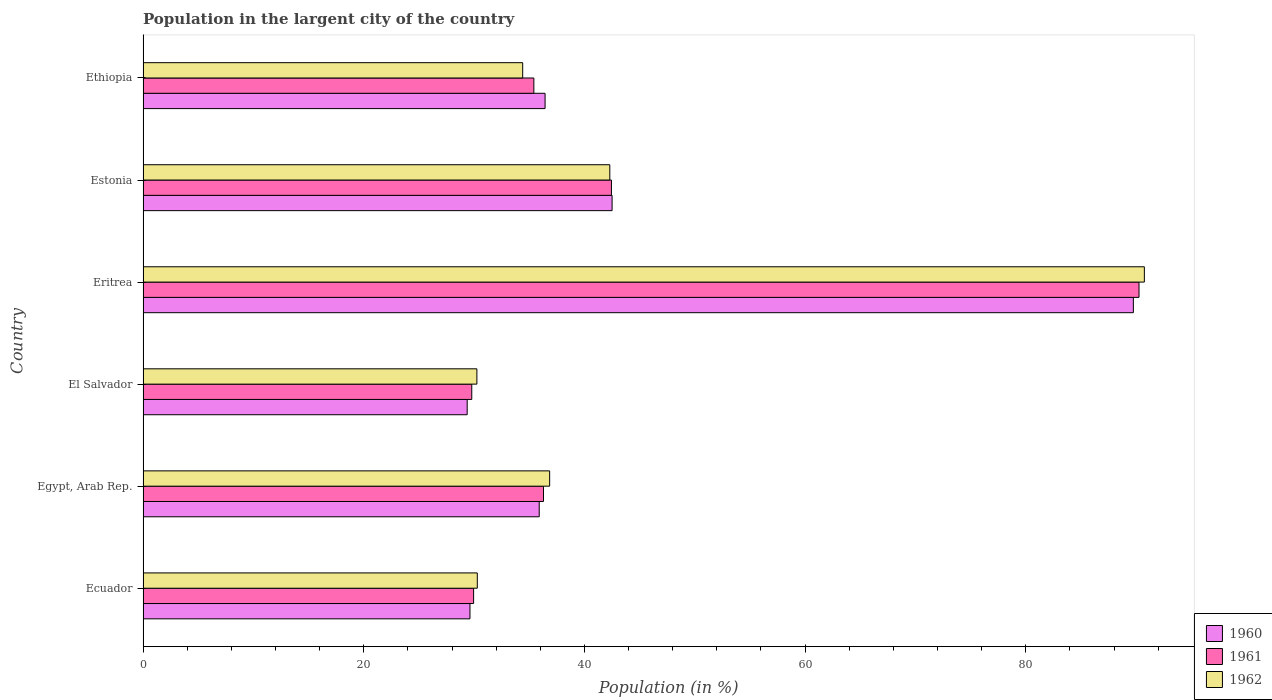Are the number of bars per tick equal to the number of legend labels?
Your answer should be very brief. Yes. Are the number of bars on each tick of the Y-axis equal?
Your answer should be very brief. Yes. How many bars are there on the 4th tick from the bottom?
Make the answer very short. 3. What is the label of the 2nd group of bars from the top?
Offer a very short reply. Estonia. What is the percentage of population in the largent city in 1960 in Eritrea?
Give a very brief answer. 89.75. Across all countries, what is the maximum percentage of population in the largent city in 1962?
Give a very brief answer. 90.74. Across all countries, what is the minimum percentage of population in the largent city in 1961?
Your answer should be very brief. 29.79. In which country was the percentage of population in the largent city in 1962 maximum?
Make the answer very short. Eritrea. In which country was the percentage of population in the largent city in 1960 minimum?
Your answer should be very brief. El Salvador. What is the total percentage of population in the largent city in 1961 in the graph?
Offer a very short reply. 264.16. What is the difference between the percentage of population in the largent city in 1960 in Egypt, Arab Rep. and that in Estonia?
Offer a terse response. -6.6. What is the difference between the percentage of population in the largent city in 1961 in El Salvador and the percentage of population in the largent city in 1962 in Estonia?
Provide a succinct answer. -12.51. What is the average percentage of population in the largent city in 1962 per country?
Keep it short and to the point. 44.14. What is the difference between the percentage of population in the largent city in 1960 and percentage of population in the largent city in 1961 in Ecuador?
Offer a terse response. -0.33. In how many countries, is the percentage of population in the largent city in 1962 greater than 40 %?
Make the answer very short. 2. What is the ratio of the percentage of population in the largent city in 1962 in Eritrea to that in Ethiopia?
Ensure brevity in your answer.  2.64. What is the difference between the highest and the second highest percentage of population in the largent city in 1960?
Ensure brevity in your answer.  47.24. What is the difference between the highest and the lowest percentage of population in the largent city in 1960?
Your response must be concise. 60.37. In how many countries, is the percentage of population in the largent city in 1960 greater than the average percentage of population in the largent city in 1960 taken over all countries?
Offer a terse response. 1. Is the sum of the percentage of population in the largent city in 1962 in Egypt, Arab Rep. and Ethiopia greater than the maximum percentage of population in the largent city in 1961 across all countries?
Make the answer very short. No. What does the 2nd bar from the top in Egypt, Arab Rep. represents?
Ensure brevity in your answer.  1961. Are all the bars in the graph horizontal?
Keep it short and to the point. Yes. How many countries are there in the graph?
Your answer should be very brief. 6. What is the difference between two consecutive major ticks on the X-axis?
Your answer should be very brief. 20. Are the values on the major ticks of X-axis written in scientific E-notation?
Give a very brief answer. No. Where does the legend appear in the graph?
Provide a succinct answer. Bottom right. What is the title of the graph?
Ensure brevity in your answer.  Population in the largent city of the country. What is the Population (in %) of 1960 in Ecuador?
Your answer should be very brief. 29.63. What is the Population (in %) in 1961 in Ecuador?
Ensure brevity in your answer.  29.96. What is the Population (in %) in 1962 in Ecuador?
Provide a succinct answer. 30.29. What is the Population (in %) of 1960 in Egypt, Arab Rep.?
Your answer should be compact. 35.9. What is the Population (in %) of 1961 in Egypt, Arab Rep.?
Give a very brief answer. 36.29. What is the Population (in %) of 1962 in Egypt, Arab Rep.?
Offer a terse response. 36.85. What is the Population (in %) in 1960 in El Salvador?
Provide a short and direct response. 29.37. What is the Population (in %) of 1961 in El Salvador?
Make the answer very short. 29.79. What is the Population (in %) in 1962 in El Salvador?
Provide a short and direct response. 30.25. What is the Population (in %) of 1960 in Eritrea?
Offer a very short reply. 89.75. What is the Population (in %) of 1961 in Eritrea?
Ensure brevity in your answer.  90.26. What is the Population (in %) of 1962 in Eritrea?
Offer a very short reply. 90.74. What is the Population (in %) of 1960 in Estonia?
Your answer should be compact. 42.51. What is the Population (in %) in 1961 in Estonia?
Your answer should be very brief. 42.45. What is the Population (in %) in 1962 in Estonia?
Give a very brief answer. 42.3. What is the Population (in %) of 1960 in Ethiopia?
Your answer should be very brief. 36.43. What is the Population (in %) of 1961 in Ethiopia?
Give a very brief answer. 35.42. What is the Population (in %) of 1962 in Ethiopia?
Keep it short and to the point. 34.4. Across all countries, what is the maximum Population (in %) in 1960?
Ensure brevity in your answer.  89.75. Across all countries, what is the maximum Population (in %) in 1961?
Your answer should be very brief. 90.26. Across all countries, what is the maximum Population (in %) in 1962?
Offer a very short reply. 90.74. Across all countries, what is the minimum Population (in %) of 1960?
Your answer should be compact. 29.37. Across all countries, what is the minimum Population (in %) in 1961?
Provide a succinct answer. 29.79. Across all countries, what is the minimum Population (in %) in 1962?
Offer a very short reply. 30.25. What is the total Population (in %) in 1960 in the graph?
Offer a terse response. 263.59. What is the total Population (in %) of 1961 in the graph?
Your response must be concise. 264.16. What is the total Population (in %) in 1962 in the graph?
Your answer should be very brief. 264.84. What is the difference between the Population (in %) of 1960 in Ecuador and that in Egypt, Arab Rep.?
Give a very brief answer. -6.28. What is the difference between the Population (in %) in 1961 in Ecuador and that in Egypt, Arab Rep.?
Give a very brief answer. -6.33. What is the difference between the Population (in %) of 1962 in Ecuador and that in Egypt, Arab Rep.?
Offer a very short reply. -6.56. What is the difference between the Population (in %) of 1960 in Ecuador and that in El Salvador?
Offer a very short reply. 0.25. What is the difference between the Population (in %) of 1961 in Ecuador and that in El Salvador?
Make the answer very short. 0.17. What is the difference between the Population (in %) in 1962 in Ecuador and that in El Salvador?
Keep it short and to the point. 0.04. What is the difference between the Population (in %) of 1960 in Ecuador and that in Eritrea?
Offer a very short reply. -60.12. What is the difference between the Population (in %) of 1961 in Ecuador and that in Eritrea?
Offer a very short reply. -60.3. What is the difference between the Population (in %) of 1962 in Ecuador and that in Eritrea?
Your answer should be compact. -60.45. What is the difference between the Population (in %) in 1960 in Ecuador and that in Estonia?
Make the answer very short. -12.88. What is the difference between the Population (in %) in 1961 in Ecuador and that in Estonia?
Your answer should be compact. -12.49. What is the difference between the Population (in %) in 1962 in Ecuador and that in Estonia?
Offer a terse response. -12.01. What is the difference between the Population (in %) in 1960 in Ecuador and that in Ethiopia?
Make the answer very short. -6.81. What is the difference between the Population (in %) of 1961 in Ecuador and that in Ethiopia?
Give a very brief answer. -5.46. What is the difference between the Population (in %) of 1962 in Ecuador and that in Ethiopia?
Your response must be concise. -4.11. What is the difference between the Population (in %) of 1960 in Egypt, Arab Rep. and that in El Salvador?
Provide a succinct answer. 6.53. What is the difference between the Population (in %) of 1961 in Egypt, Arab Rep. and that in El Salvador?
Keep it short and to the point. 6.5. What is the difference between the Population (in %) of 1962 in Egypt, Arab Rep. and that in El Salvador?
Your response must be concise. 6.59. What is the difference between the Population (in %) in 1960 in Egypt, Arab Rep. and that in Eritrea?
Give a very brief answer. -53.85. What is the difference between the Population (in %) of 1961 in Egypt, Arab Rep. and that in Eritrea?
Your answer should be compact. -53.97. What is the difference between the Population (in %) in 1962 in Egypt, Arab Rep. and that in Eritrea?
Your response must be concise. -53.9. What is the difference between the Population (in %) in 1960 in Egypt, Arab Rep. and that in Estonia?
Offer a very short reply. -6.61. What is the difference between the Population (in %) in 1961 in Egypt, Arab Rep. and that in Estonia?
Your answer should be very brief. -6.16. What is the difference between the Population (in %) in 1962 in Egypt, Arab Rep. and that in Estonia?
Make the answer very short. -5.45. What is the difference between the Population (in %) in 1960 in Egypt, Arab Rep. and that in Ethiopia?
Make the answer very short. -0.53. What is the difference between the Population (in %) of 1961 in Egypt, Arab Rep. and that in Ethiopia?
Your answer should be compact. 0.87. What is the difference between the Population (in %) in 1962 in Egypt, Arab Rep. and that in Ethiopia?
Give a very brief answer. 2.44. What is the difference between the Population (in %) in 1960 in El Salvador and that in Eritrea?
Provide a short and direct response. -60.37. What is the difference between the Population (in %) in 1961 in El Salvador and that in Eritrea?
Keep it short and to the point. -60.47. What is the difference between the Population (in %) in 1962 in El Salvador and that in Eritrea?
Provide a succinct answer. -60.49. What is the difference between the Population (in %) in 1960 in El Salvador and that in Estonia?
Offer a very short reply. -13.13. What is the difference between the Population (in %) of 1961 in El Salvador and that in Estonia?
Provide a succinct answer. -12.66. What is the difference between the Population (in %) of 1962 in El Salvador and that in Estonia?
Provide a short and direct response. -12.05. What is the difference between the Population (in %) in 1960 in El Salvador and that in Ethiopia?
Provide a short and direct response. -7.06. What is the difference between the Population (in %) of 1961 in El Salvador and that in Ethiopia?
Offer a very short reply. -5.63. What is the difference between the Population (in %) in 1962 in El Salvador and that in Ethiopia?
Your response must be concise. -4.15. What is the difference between the Population (in %) in 1960 in Eritrea and that in Estonia?
Your answer should be very brief. 47.24. What is the difference between the Population (in %) in 1961 in Eritrea and that in Estonia?
Offer a very short reply. 47.81. What is the difference between the Population (in %) of 1962 in Eritrea and that in Estonia?
Keep it short and to the point. 48.44. What is the difference between the Population (in %) in 1960 in Eritrea and that in Ethiopia?
Provide a succinct answer. 53.31. What is the difference between the Population (in %) of 1961 in Eritrea and that in Ethiopia?
Your answer should be very brief. 54.84. What is the difference between the Population (in %) in 1962 in Eritrea and that in Ethiopia?
Keep it short and to the point. 56.34. What is the difference between the Population (in %) in 1960 in Estonia and that in Ethiopia?
Provide a short and direct response. 6.07. What is the difference between the Population (in %) of 1961 in Estonia and that in Ethiopia?
Give a very brief answer. 7.03. What is the difference between the Population (in %) in 1962 in Estonia and that in Ethiopia?
Keep it short and to the point. 7.9. What is the difference between the Population (in %) in 1960 in Ecuador and the Population (in %) in 1961 in Egypt, Arab Rep.?
Give a very brief answer. -6.66. What is the difference between the Population (in %) of 1960 in Ecuador and the Population (in %) of 1962 in Egypt, Arab Rep.?
Offer a terse response. -7.22. What is the difference between the Population (in %) in 1961 in Ecuador and the Population (in %) in 1962 in Egypt, Arab Rep.?
Keep it short and to the point. -6.89. What is the difference between the Population (in %) in 1960 in Ecuador and the Population (in %) in 1961 in El Salvador?
Ensure brevity in your answer.  -0.16. What is the difference between the Population (in %) in 1960 in Ecuador and the Population (in %) in 1962 in El Salvador?
Provide a short and direct response. -0.63. What is the difference between the Population (in %) of 1961 in Ecuador and the Population (in %) of 1962 in El Salvador?
Make the answer very short. -0.3. What is the difference between the Population (in %) of 1960 in Ecuador and the Population (in %) of 1961 in Eritrea?
Your response must be concise. -60.63. What is the difference between the Population (in %) of 1960 in Ecuador and the Population (in %) of 1962 in Eritrea?
Offer a terse response. -61.12. What is the difference between the Population (in %) of 1961 in Ecuador and the Population (in %) of 1962 in Eritrea?
Your answer should be very brief. -60.79. What is the difference between the Population (in %) of 1960 in Ecuador and the Population (in %) of 1961 in Estonia?
Make the answer very short. -12.82. What is the difference between the Population (in %) in 1960 in Ecuador and the Population (in %) in 1962 in Estonia?
Offer a very short reply. -12.67. What is the difference between the Population (in %) in 1961 in Ecuador and the Population (in %) in 1962 in Estonia?
Your response must be concise. -12.34. What is the difference between the Population (in %) in 1960 in Ecuador and the Population (in %) in 1961 in Ethiopia?
Make the answer very short. -5.79. What is the difference between the Population (in %) in 1960 in Ecuador and the Population (in %) in 1962 in Ethiopia?
Your response must be concise. -4.78. What is the difference between the Population (in %) in 1961 in Ecuador and the Population (in %) in 1962 in Ethiopia?
Ensure brevity in your answer.  -4.45. What is the difference between the Population (in %) in 1960 in Egypt, Arab Rep. and the Population (in %) in 1961 in El Salvador?
Provide a short and direct response. 6.11. What is the difference between the Population (in %) of 1960 in Egypt, Arab Rep. and the Population (in %) of 1962 in El Salvador?
Give a very brief answer. 5.65. What is the difference between the Population (in %) of 1961 in Egypt, Arab Rep. and the Population (in %) of 1962 in El Salvador?
Your answer should be very brief. 6.04. What is the difference between the Population (in %) of 1960 in Egypt, Arab Rep. and the Population (in %) of 1961 in Eritrea?
Keep it short and to the point. -54.36. What is the difference between the Population (in %) in 1960 in Egypt, Arab Rep. and the Population (in %) in 1962 in Eritrea?
Offer a very short reply. -54.84. What is the difference between the Population (in %) in 1961 in Egypt, Arab Rep. and the Population (in %) in 1962 in Eritrea?
Offer a terse response. -54.46. What is the difference between the Population (in %) of 1960 in Egypt, Arab Rep. and the Population (in %) of 1961 in Estonia?
Provide a short and direct response. -6.54. What is the difference between the Population (in %) in 1960 in Egypt, Arab Rep. and the Population (in %) in 1962 in Estonia?
Make the answer very short. -6.4. What is the difference between the Population (in %) in 1961 in Egypt, Arab Rep. and the Population (in %) in 1962 in Estonia?
Offer a terse response. -6.01. What is the difference between the Population (in %) in 1960 in Egypt, Arab Rep. and the Population (in %) in 1961 in Ethiopia?
Keep it short and to the point. 0.49. What is the difference between the Population (in %) of 1960 in Egypt, Arab Rep. and the Population (in %) of 1962 in Ethiopia?
Provide a short and direct response. 1.5. What is the difference between the Population (in %) in 1961 in Egypt, Arab Rep. and the Population (in %) in 1962 in Ethiopia?
Offer a very short reply. 1.88. What is the difference between the Population (in %) in 1960 in El Salvador and the Population (in %) in 1961 in Eritrea?
Provide a succinct answer. -60.89. What is the difference between the Population (in %) of 1960 in El Salvador and the Population (in %) of 1962 in Eritrea?
Provide a short and direct response. -61.37. What is the difference between the Population (in %) in 1961 in El Salvador and the Population (in %) in 1962 in Eritrea?
Keep it short and to the point. -60.96. What is the difference between the Population (in %) in 1960 in El Salvador and the Population (in %) in 1961 in Estonia?
Provide a succinct answer. -13.07. What is the difference between the Population (in %) of 1960 in El Salvador and the Population (in %) of 1962 in Estonia?
Your answer should be compact. -12.93. What is the difference between the Population (in %) in 1961 in El Salvador and the Population (in %) in 1962 in Estonia?
Keep it short and to the point. -12.51. What is the difference between the Population (in %) of 1960 in El Salvador and the Population (in %) of 1961 in Ethiopia?
Give a very brief answer. -6.04. What is the difference between the Population (in %) of 1960 in El Salvador and the Population (in %) of 1962 in Ethiopia?
Provide a short and direct response. -5.03. What is the difference between the Population (in %) in 1961 in El Salvador and the Population (in %) in 1962 in Ethiopia?
Your answer should be very brief. -4.61. What is the difference between the Population (in %) in 1960 in Eritrea and the Population (in %) in 1961 in Estonia?
Provide a succinct answer. 47.3. What is the difference between the Population (in %) of 1960 in Eritrea and the Population (in %) of 1962 in Estonia?
Keep it short and to the point. 47.45. What is the difference between the Population (in %) of 1961 in Eritrea and the Population (in %) of 1962 in Estonia?
Provide a short and direct response. 47.96. What is the difference between the Population (in %) of 1960 in Eritrea and the Population (in %) of 1961 in Ethiopia?
Provide a succinct answer. 54.33. What is the difference between the Population (in %) of 1960 in Eritrea and the Population (in %) of 1962 in Ethiopia?
Make the answer very short. 55.34. What is the difference between the Population (in %) in 1961 in Eritrea and the Population (in %) in 1962 in Ethiopia?
Your answer should be very brief. 55.86. What is the difference between the Population (in %) in 1960 in Estonia and the Population (in %) in 1961 in Ethiopia?
Make the answer very short. 7.09. What is the difference between the Population (in %) in 1960 in Estonia and the Population (in %) in 1962 in Ethiopia?
Your answer should be very brief. 8.1. What is the difference between the Population (in %) in 1961 in Estonia and the Population (in %) in 1962 in Ethiopia?
Your answer should be very brief. 8.04. What is the average Population (in %) of 1960 per country?
Offer a terse response. 43.93. What is the average Population (in %) of 1961 per country?
Make the answer very short. 44.03. What is the average Population (in %) of 1962 per country?
Provide a short and direct response. 44.14. What is the difference between the Population (in %) of 1960 and Population (in %) of 1961 in Ecuador?
Your response must be concise. -0.33. What is the difference between the Population (in %) of 1960 and Population (in %) of 1962 in Ecuador?
Your answer should be compact. -0.66. What is the difference between the Population (in %) of 1961 and Population (in %) of 1962 in Ecuador?
Your answer should be very brief. -0.33. What is the difference between the Population (in %) of 1960 and Population (in %) of 1961 in Egypt, Arab Rep.?
Your response must be concise. -0.39. What is the difference between the Population (in %) of 1960 and Population (in %) of 1962 in Egypt, Arab Rep.?
Provide a short and direct response. -0.95. What is the difference between the Population (in %) in 1961 and Population (in %) in 1962 in Egypt, Arab Rep.?
Make the answer very short. -0.56. What is the difference between the Population (in %) of 1960 and Population (in %) of 1961 in El Salvador?
Your response must be concise. -0.42. What is the difference between the Population (in %) of 1960 and Population (in %) of 1962 in El Salvador?
Provide a succinct answer. -0.88. What is the difference between the Population (in %) in 1961 and Population (in %) in 1962 in El Salvador?
Your response must be concise. -0.46. What is the difference between the Population (in %) in 1960 and Population (in %) in 1961 in Eritrea?
Provide a succinct answer. -0.51. What is the difference between the Population (in %) in 1960 and Population (in %) in 1962 in Eritrea?
Provide a short and direct response. -1. What is the difference between the Population (in %) of 1961 and Population (in %) of 1962 in Eritrea?
Give a very brief answer. -0.49. What is the difference between the Population (in %) of 1960 and Population (in %) of 1961 in Estonia?
Your answer should be very brief. 0.06. What is the difference between the Population (in %) of 1960 and Population (in %) of 1962 in Estonia?
Provide a short and direct response. 0.21. What is the difference between the Population (in %) in 1961 and Population (in %) in 1962 in Estonia?
Offer a terse response. 0.15. What is the difference between the Population (in %) in 1960 and Population (in %) in 1961 in Ethiopia?
Your response must be concise. 1.02. What is the difference between the Population (in %) of 1960 and Population (in %) of 1962 in Ethiopia?
Ensure brevity in your answer.  2.03. What is the difference between the Population (in %) of 1961 and Population (in %) of 1962 in Ethiopia?
Offer a very short reply. 1.01. What is the ratio of the Population (in %) in 1960 in Ecuador to that in Egypt, Arab Rep.?
Ensure brevity in your answer.  0.83. What is the ratio of the Population (in %) in 1961 in Ecuador to that in Egypt, Arab Rep.?
Your response must be concise. 0.83. What is the ratio of the Population (in %) in 1962 in Ecuador to that in Egypt, Arab Rep.?
Offer a very short reply. 0.82. What is the ratio of the Population (in %) of 1960 in Ecuador to that in El Salvador?
Offer a terse response. 1.01. What is the ratio of the Population (in %) of 1961 in Ecuador to that in El Salvador?
Your answer should be very brief. 1.01. What is the ratio of the Population (in %) of 1962 in Ecuador to that in El Salvador?
Provide a short and direct response. 1. What is the ratio of the Population (in %) of 1960 in Ecuador to that in Eritrea?
Provide a succinct answer. 0.33. What is the ratio of the Population (in %) of 1961 in Ecuador to that in Eritrea?
Your answer should be compact. 0.33. What is the ratio of the Population (in %) in 1962 in Ecuador to that in Eritrea?
Make the answer very short. 0.33. What is the ratio of the Population (in %) in 1960 in Ecuador to that in Estonia?
Keep it short and to the point. 0.7. What is the ratio of the Population (in %) of 1961 in Ecuador to that in Estonia?
Your answer should be compact. 0.71. What is the ratio of the Population (in %) of 1962 in Ecuador to that in Estonia?
Provide a succinct answer. 0.72. What is the ratio of the Population (in %) in 1960 in Ecuador to that in Ethiopia?
Your answer should be very brief. 0.81. What is the ratio of the Population (in %) in 1961 in Ecuador to that in Ethiopia?
Your answer should be very brief. 0.85. What is the ratio of the Population (in %) of 1962 in Ecuador to that in Ethiopia?
Provide a succinct answer. 0.88. What is the ratio of the Population (in %) in 1960 in Egypt, Arab Rep. to that in El Salvador?
Offer a terse response. 1.22. What is the ratio of the Population (in %) in 1961 in Egypt, Arab Rep. to that in El Salvador?
Offer a very short reply. 1.22. What is the ratio of the Population (in %) of 1962 in Egypt, Arab Rep. to that in El Salvador?
Make the answer very short. 1.22. What is the ratio of the Population (in %) in 1960 in Egypt, Arab Rep. to that in Eritrea?
Make the answer very short. 0.4. What is the ratio of the Population (in %) in 1961 in Egypt, Arab Rep. to that in Eritrea?
Offer a very short reply. 0.4. What is the ratio of the Population (in %) of 1962 in Egypt, Arab Rep. to that in Eritrea?
Ensure brevity in your answer.  0.41. What is the ratio of the Population (in %) of 1960 in Egypt, Arab Rep. to that in Estonia?
Make the answer very short. 0.84. What is the ratio of the Population (in %) in 1961 in Egypt, Arab Rep. to that in Estonia?
Keep it short and to the point. 0.85. What is the ratio of the Population (in %) in 1962 in Egypt, Arab Rep. to that in Estonia?
Your answer should be compact. 0.87. What is the ratio of the Population (in %) of 1960 in Egypt, Arab Rep. to that in Ethiopia?
Your response must be concise. 0.99. What is the ratio of the Population (in %) in 1961 in Egypt, Arab Rep. to that in Ethiopia?
Provide a short and direct response. 1.02. What is the ratio of the Population (in %) in 1962 in Egypt, Arab Rep. to that in Ethiopia?
Your answer should be compact. 1.07. What is the ratio of the Population (in %) of 1960 in El Salvador to that in Eritrea?
Provide a short and direct response. 0.33. What is the ratio of the Population (in %) of 1961 in El Salvador to that in Eritrea?
Ensure brevity in your answer.  0.33. What is the ratio of the Population (in %) of 1962 in El Salvador to that in Eritrea?
Keep it short and to the point. 0.33. What is the ratio of the Population (in %) in 1960 in El Salvador to that in Estonia?
Your answer should be compact. 0.69. What is the ratio of the Population (in %) in 1961 in El Salvador to that in Estonia?
Your response must be concise. 0.7. What is the ratio of the Population (in %) of 1962 in El Salvador to that in Estonia?
Provide a succinct answer. 0.72. What is the ratio of the Population (in %) in 1960 in El Salvador to that in Ethiopia?
Provide a short and direct response. 0.81. What is the ratio of the Population (in %) of 1961 in El Salvador to that in Ethiopia?
Give a very brief answer. 0.84. What is the ratio of the Population (in %) in 1962 in El Salvador to that in Ethiopia?
Provide a succinct answer. 0.88. What is the ratio of the Population (in %) of 1960 in Eritrea to that in Estonia?
Your answer should be very brief. 2.11. What is the ratio of the Population (in %) in 1961 in Eritrea to that in Estonia?
Make the answer very short. 2.13. What is the ratio of the Population (in %) in 1962 in Eritrea to that in Estonia?
Offer a very short reply. 2.15. What is the ratio of the Population (in %) of 1960 in Eritrea to that in Ethiopia?
Your answer should be compact. 2.46. What is the ratio of the Population (in %) in 1961 in Eritrea to that in Ethiopia?
Ensure brevity in your answer.  2.55. What is the ratio of the Population (in %) in 1962 in Eritrea to that in Ethiopia?
Ensure brevity in your answer.  2.64. What is the ratio of the Population (in %) of 1960 in Estonia to that in Ethiopia?
Give a very brief answer. 1.17. What is the ratio of the Population (in %) of 1961 in Estonia to that in Ethiopia?
Give a very brief answer. 1.2. What is the ratio of the Population (in %) in 1962 in Estonia to that in Ethiopia?
Provide a short and direct response. 1.23. What is the difference between the highest and the second highest Population (in %) of 1960?
Provide a short and direct response. 47.24. What is the difference between the highest and the second highest Population (in %) of 1961?
Make the answer very short. 47.81. What is the difference between the highest and the second highest Population (in %) in 1962?
Provide a succinct answer. 48.44. What is the difference between the highest and the lowest Population (in %) of 1960?
Your answer should be very brief. 60.37. What is the difference between the highest and the lowest Population (in %) of 1961?
Make the answer very short. 60.47. What is the difference between the highest and the lowest Population (in %) in 1962?
Provide a succinct answer. 60.49. 